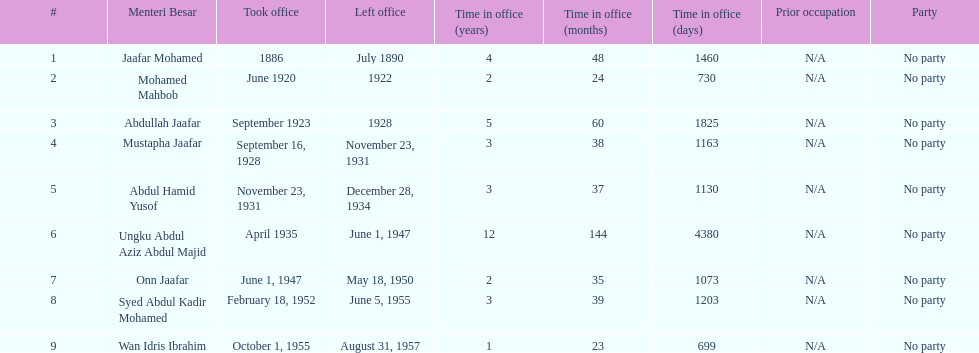What is the number of menteri besar that served 4 or more years? 3. Would you mind parsing the complete table? {'header': ['#', 'Menteri Besar', 'Took office', 'Left office', 'Time in office (years)', 'Time in office (months)', 'Time in office (days)', 'Prior occupation', 'Party'], 'rows': [['1', 'Jaafar Mohamed', '1886', 'July 1890', '4', '48', '1460', 'N/A', 'No party'], ['2', 'Mohamed Mahbob', 'June 1920', '1922', '2', '24', '730', 'N/A', 'No party'], ['3', 'Abdullah Jaafar', 'September 1923', '1928', '5', '60', '1825', 'N/A', 'No party'], ['4', 'Mustapha Jaafar', 'September 16, 1928', 'November 23, 1931', '3', '38', '1163', 'N/A', 'No party'], ['5', 'Abdul Hamid Yusof', 'November 23, 1931', 'December 28, 1934', '3', '37', '1130', 'N/A', 'No party'], ['6', 'Ungku Abdul Aziz Abdul Majid', 'April 1935', 'June 1, 1947', '12', '144', '4380', 'N/A', 'No party'], ['7', 'Onn Jaafar', 'June 1, 1947', 'May 18, 1950', '2', '35', '1073', 'N/A', 'No party'], ['8', 'Syed Abdul Kadir Mohamed', 'February 18, 1952', 'June 5, 1955', '3', '39', '1203', 'N/A', 'No party'], ['9', 'Wan Idris Ibrahim', 'October 1, 1955', 'August 31, 1957', '1', '23', '699', 'N/A', 'No party']]} 